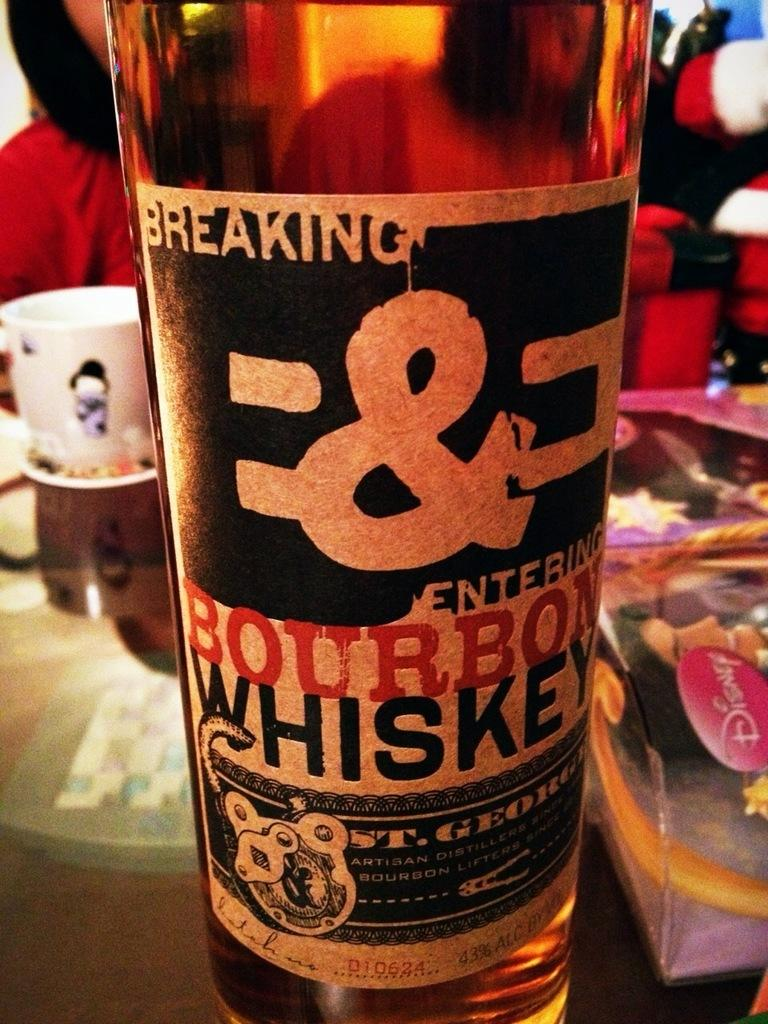<image>
Present a compact description of the photo's key features. Breaking & Entering Bourbon Whiskey setting on the table infront of a man with a hoodie on. 